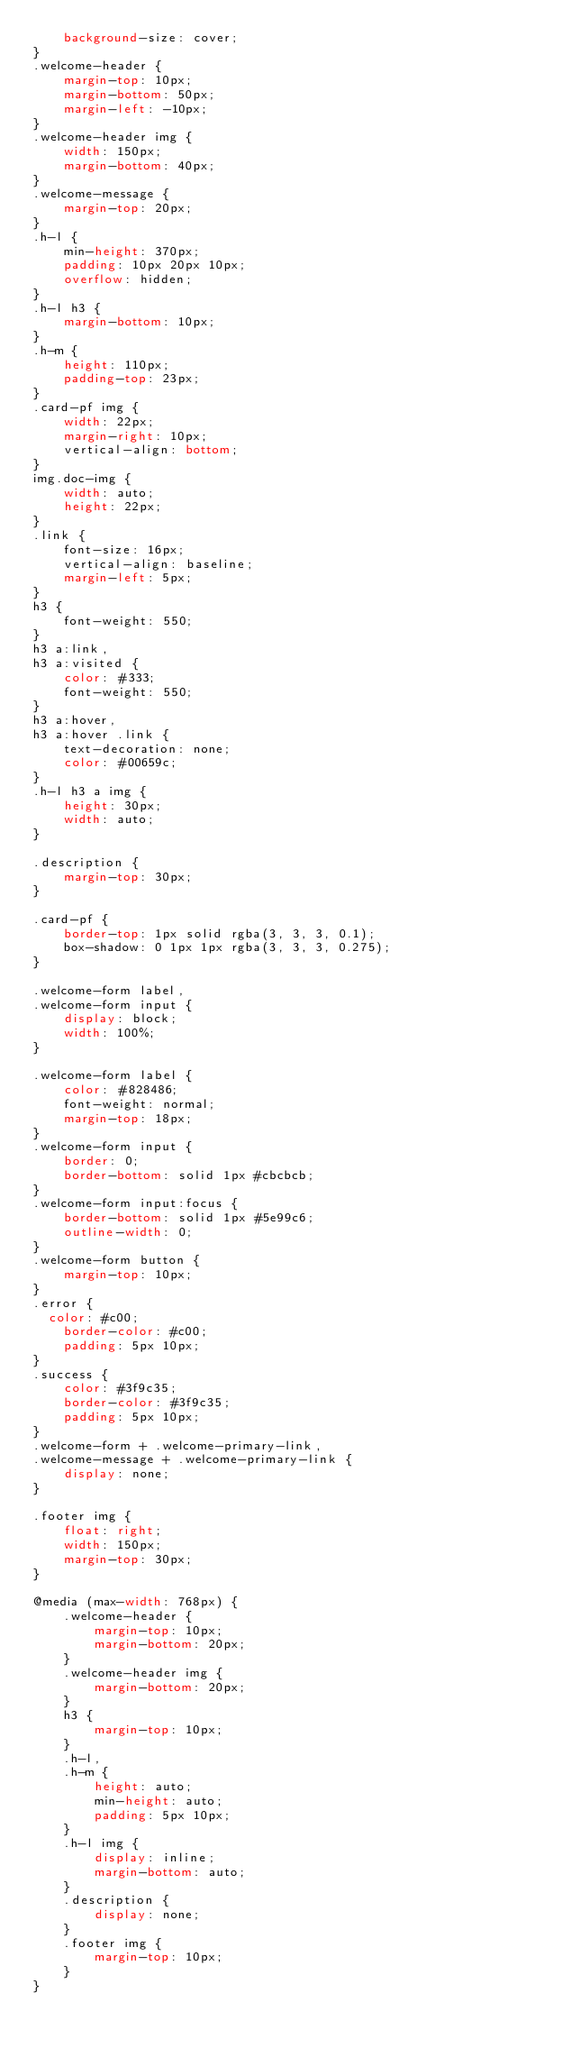Convert code to text. <code><loc_0><loc_0><loc_500><loc_500><_CSS_>    background-size: cover;
}
.welcome-header {
    margin-top: 10px;
    margin-bottom: 50px;
    margin-left: -10px;
}
.welcome-header img {
    width: 150px;
    margin-bottom: 40px;
}
.welcome-message {
    margin-top: 20px;
}
.h-l {
    min-height: 370px;
    padding: 10px 20px 10px;
    overflow: hidden;
}
.h-l h3 {
    margin-bottom: 10px;
}
.h-m {
    height: 110px;
    padding-top: 23px;
}
.card-pf img {
    width: 22px;
    margin-right: 10px;
    vertical-align: bottom;
}
img.doc-img {
    width: auto;
    height: 22px;
}
.link {
    font-size: 16px;
    vertical-align: baseline;
    margin-left: 5px;
}
h3 {
    font-weight: 550;
}
h3 a:link,
h3 a:visited {
    color: #333;
    font-weight: 550;
}
h3 a:hover,
h3 a:hover .link {
    text-decoration: none;
    color: #00659c;
}
.h-l h3 a img {
    height: 30px;
    width: auto;
}

.description {
    margin-top: 30px;
}

.card-pf {
    border-top: 1px solid rgba(3, 3, 3, 0.1);
    box-shadow: 0 1px 1px rgba(3, 3, 3, 0.275);
}

.welcome-form label,
.welcome-form input {
    display: block;
    width: 100%;
}

.welcome-form label {
    color: #828486;
    font-weight: normal;
    margin-top: 18px;
}
.welcome-form input {
    border: 0;
    border-bottom: solid 1px #cbcbcb;
}
.welcome-form input:focus {
    border-bottom: solid 1px #5e99c6;
    outline-width: 0;
}
.welcome-form button {
    margin-top: 10px;
}
.error {
  color: #c00;
    border-color: #c00;
    padding: 5px 10px;
}
.success {
    color: #3f9c35;
    border-color: #3f9c35;
    padding: 5px 10px;
}
.welcome-form + .welcome-primary-link,
.welcome-message + .welcome-primary-link {
    display: none;
}

.footer img {
    float: right;
    width: 150px;
    margin-top: 30px;
}

@media (max-width: 768px) {
    .welcome-header {
        margin-top: 10px;
        margin-bottom: 20px;
    }
    .welcome-header img {
        margin-bottom: 20px;
    }
    h3 {
        margin-top: 10px;
    }
    .h-l,
    .h-m {
        height: auto;
        min-height: auto;
        padding: 5px 10px;
    }
    .h-l img {
        display: inline;
        margin-bottom: auto;
    }
    .description {
        display: none;
    }
    .footer img {
        margin-top: 10px;
    }
}
</code> 